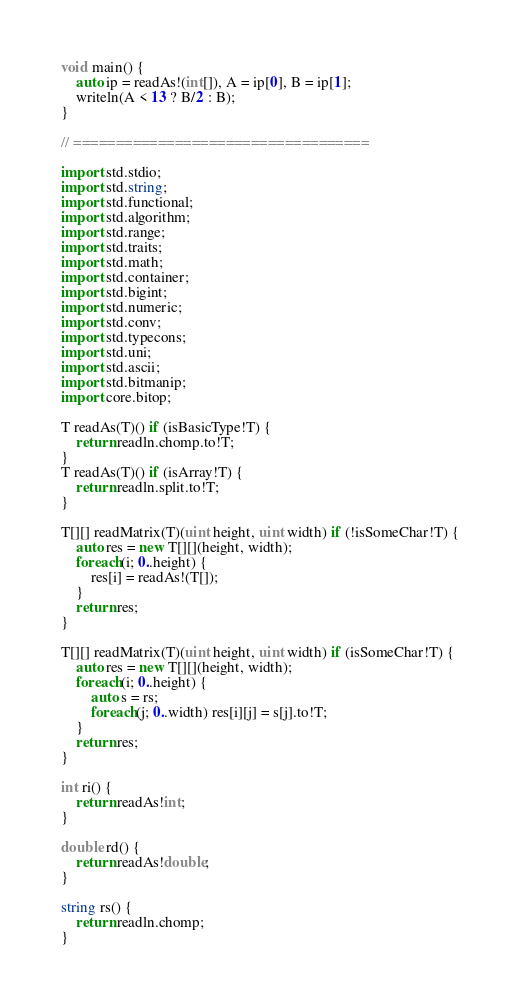<code> <loc_0><loc_0><loc_500><loc_500><_D_>void main() {
	auto ip = readAs!(int[]), A = ip[0], B = ip[1];
	writeln(A < 13 ? B/2 : B);
}

// ===================================

import std.stdio;
import std.string;
import std.functional;
import std.algorithm;
import std.range;
import std.traits;
import std.math;
import std.container;
import std.bigint;
import std.numeric;
import std.conv;
import std.typecons;
import std.uni;
import std.ascii;
import std.bitmanip;
import core.bitop;

T readAs(T)() if (isBasicType!T) {
	return readln.chomp.to!T;
}
T readAs(T)() if (isArray!T) {
	return readln.split.to!T;
}

T[][] readMatrix(T)(uint height, uint width) if (!isSomeChar!T) {
	auto res = new T[][](height, width);
	foreach(i; 0..height) {
		res[i] = readAs!(T[]);
	}
	return res;
}

T[][] readMatrix(T)(uint height, uint width) if (isSomeChar!T) {
	auto res = new T[][](height, width);
	foreach(i; 0..height) {
		auto s = rs;
		foreach(j; 0..width) res[i][j] = s[j].to!T;
	}
	return res;
}

int ri() {
	return readAs!int;
}

double rd() {
	return readAs!double;
}

string rs() {
	return readln.chomp;
}</code> 